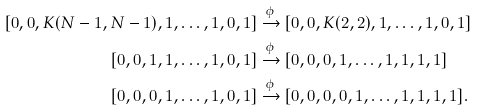<formula> <loc_0><loc_0><loc_500><loc_500>[ 0 , 0 , K ( N - 1 , N - 1 ) , 1 , \dots , 1 , 0 , 1 ] & \xrightarrow { \phi } [ 0 , 0 , K ( 2 , 2 ) , 1 , \dots , 1 , 0 , 1 ] \\ [ 0 , 0 , 1 , 1 , \dots , 1 , 0 , 1 ] & \xrightarrow { \phi } [ 0 , 0 , 0 , 1 , \dots , 1 , 1 , 1 , 1 ] \\ [ 0 , 0 , 0 , 1 , \dots , 1 , 0 , 1 ] & \xrightarrow { \phi } [ 0 , 0 , 0 , 0 , 1 , \dots , 1 , 1 , 1 , 1 ] .</formula> 